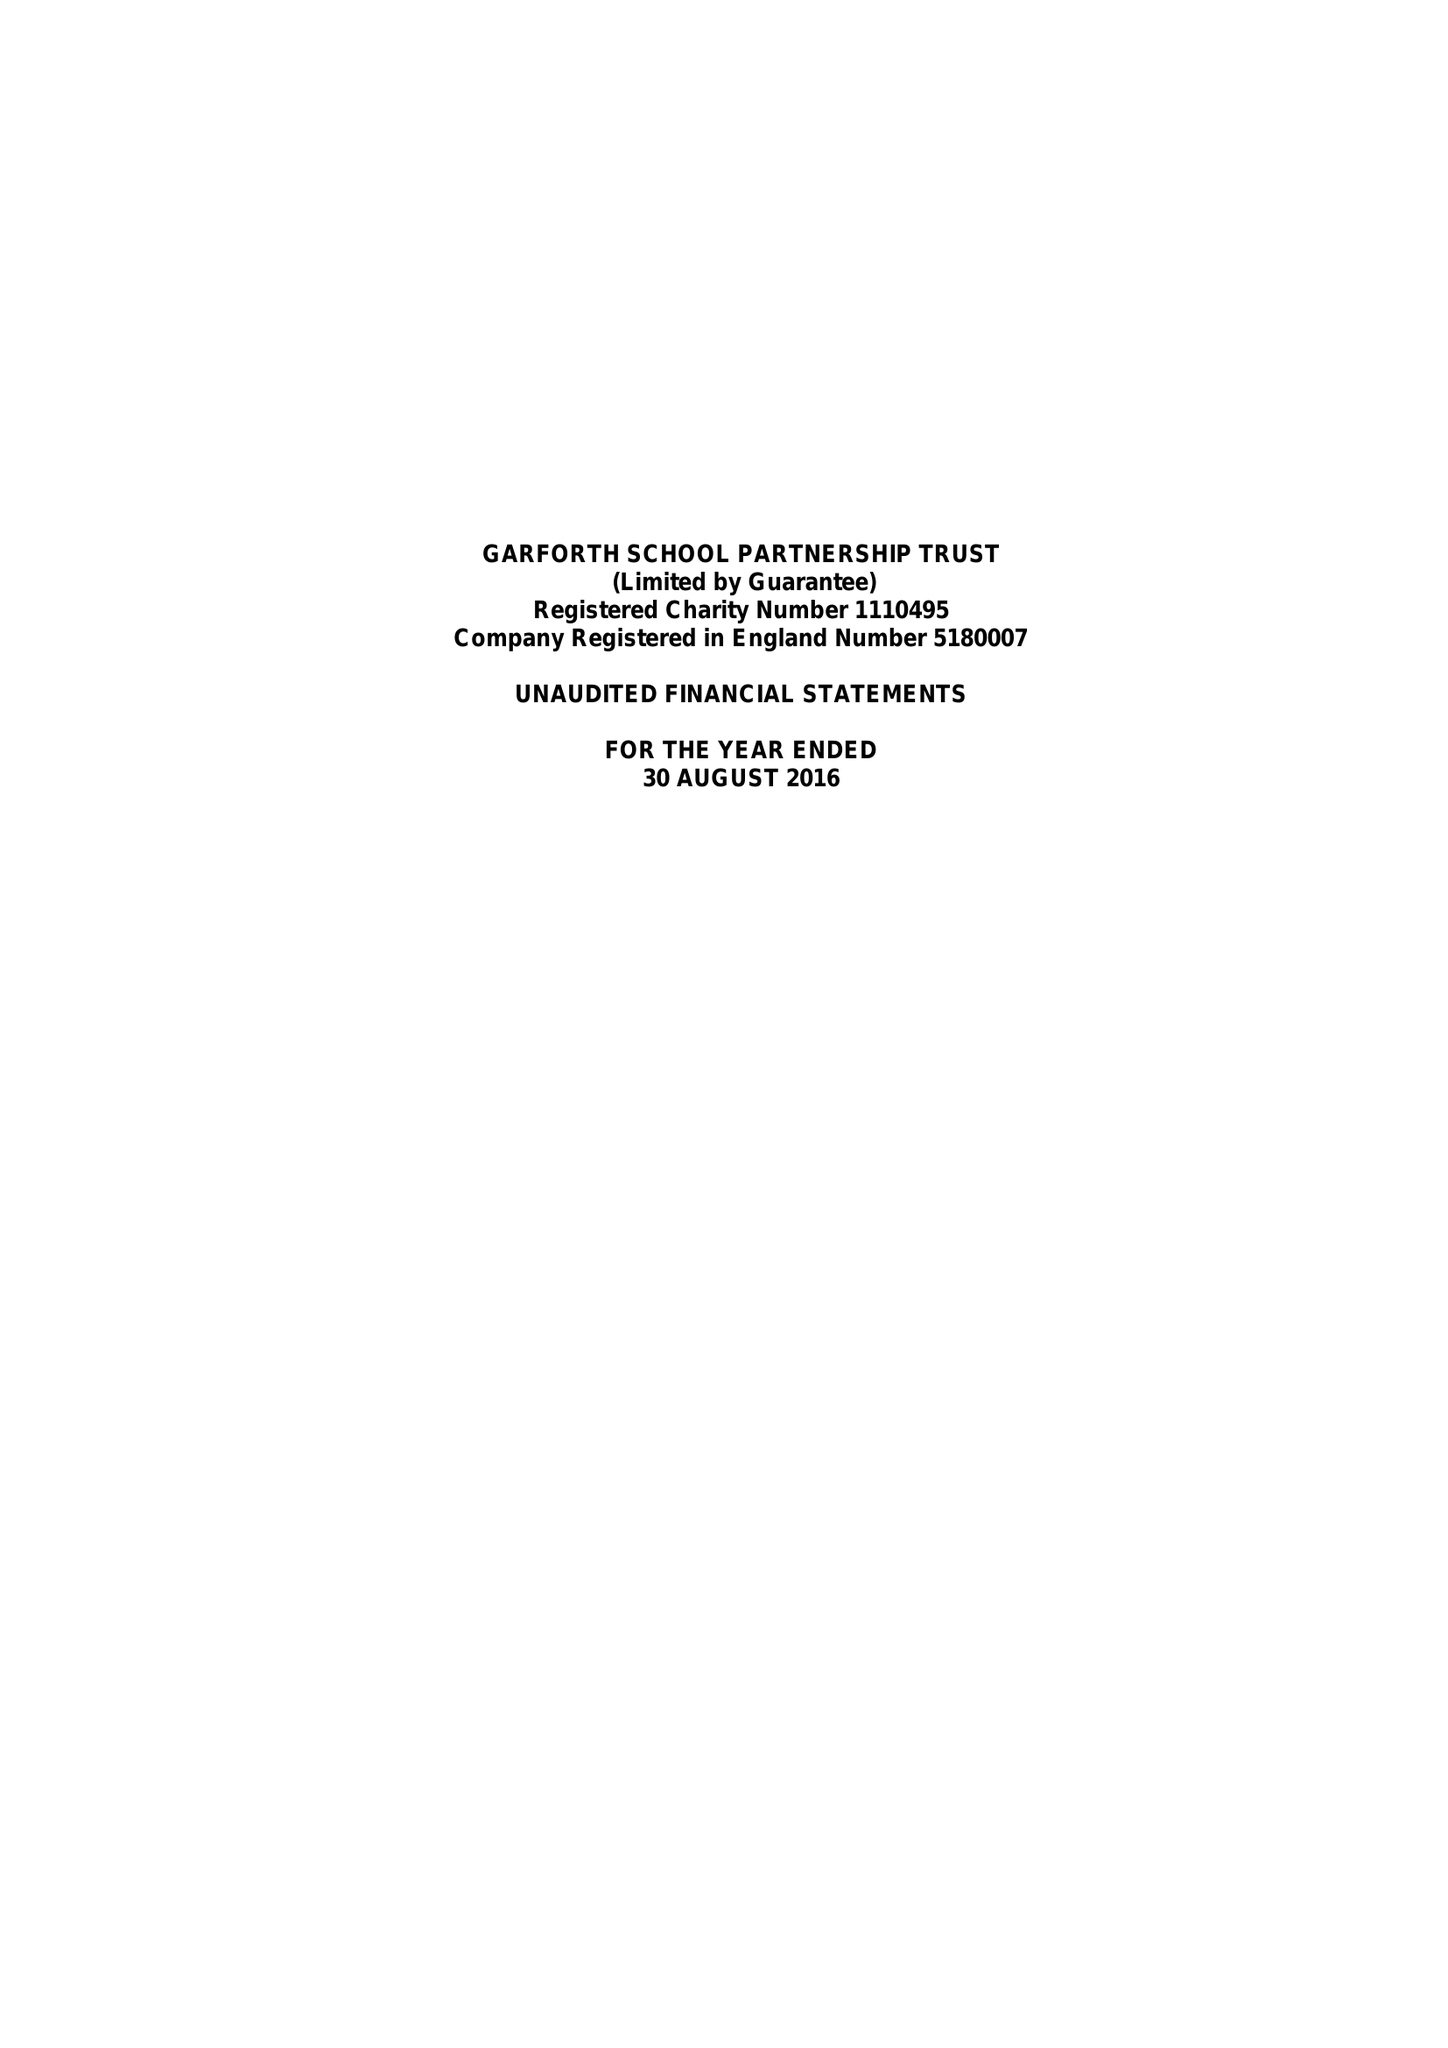What is the value for the charity_number?
Answer the question using a single word or phrase. 1110495 